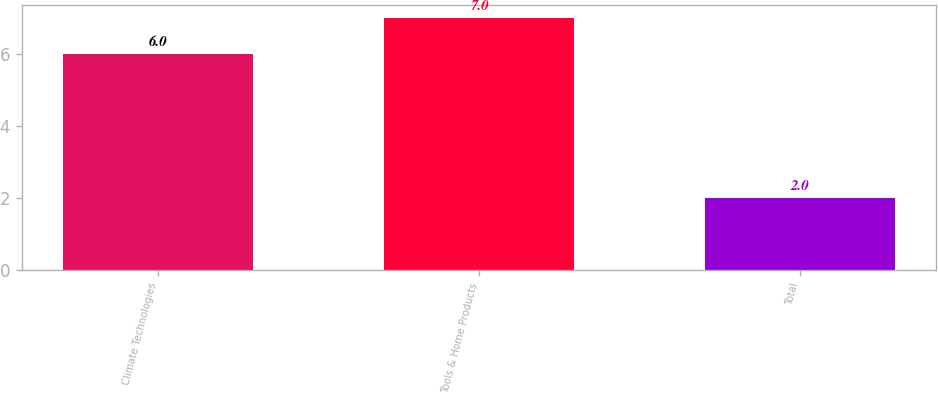<chart> <loc_0><loc_0><loc_500><loc_500><bar_chart><fcel>Climate Technologies<fcel>Tools & Home Products<fcel>Total<nl><fcel>6<fcel>7<fcel>2<nl></chart> 